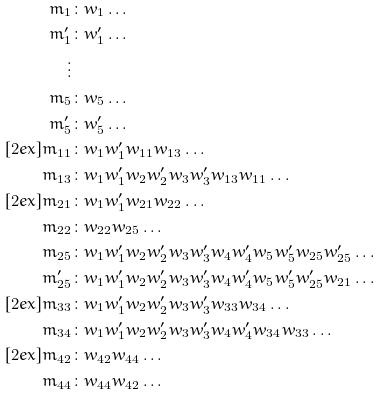<formula> <loc_0><loc_0><loc_500><loc_500>m _ { 1 } & \colon w _ { 1 } \dots \\ m _ { 1 } ^ { \prime } & \colon w _ { 1 } ^ { \prime } \dots \\ \vdots \\ m _ { 5 } & \colon w _ { 5 } \dots \\ m _ { 5 } ^ { \prime } & \colon w _ { 5 } ^ { \prime } \dots \\ [ 2 e x ] m _ { 1 1 } & \colon w _ { 1 } w _ { 1 } ^ { \prime } w _ { 1 1 } w _ { 1 3 } \dots \\ m _ { 1 3 } & \colon w _ { 1 } w _ { 1 } ^ { \prime } w _ { 2 } w _ { 2 } ^ { \prime } w _ { 3 } w _ { 3 } ^ { \prime } w _ { 1 3 } w _ { 1 1 } \dots \\ [ 2 e x ] m _ { 2 1 } & \colon w _ { 1 } w _ { 1 } ^ { \prime } w _ { 2 1 } w _ { 2 2 } \dots \\ m _ { 2 2 } & \colon w _ { 2 2 } w _ { 2 5 } \dots \\ m _ { 2 5 } & \colon w _ { 1 } w _ { 1 } ^ { \prime } w _ { 2 } w _ { 2 } ^ { \prime } w _ { 3 } w _ { 3 } ^ { \prime } w _ { 4 } w _ { 4 } ^ { \prime } w _ { 5 } w _ { 5 } ^ { \prime } w _ { 2 5 } w _ { 2 5 } ^ { \prime } \dots \\ m _ { 2 5 } ^ { \prime } & \colon w _ { 1 } w _ { 1 } ^ { \prime } w _ { 2 } w _ { 2 } ^ { \prime } w _ { 3 } w _ { 3 } ^ { \prime } w _ { 4 } w _ { 4 } ^ { \prime } w _ { 5 } w _ { 5 } ^ { \prime } w _ { 2 5 } ^ { \prime } w _ { 2 1 } \dots \\ [ 2 e x ] m _ { 3 3 } & \colon w _ { 1 } w _ { 1 } ^ { \prime } w _ { 2 } w _ { 2 } ^ { \prime } w _ { 3 } w _ { 3 } ^ { \prime } w _ { 3 3 } w _ { 3 4 } \dots \\ m _ { 3 4 } & \colon w _ { 1 } w _ { 1 } ^ { \prime } w _ { 2 } w _ { 2 } ^ { \prime } w _ { 3 } w _ { 3 } ^ { \prime } w _ { 4 } w _ { 4 } ^ { \prime } w _ { 3 4 } w _ { 3 3 } \dots \\ [ 2 e x ] m _ { 4 2 } & \colon w _ { 4 2 } w _ { 4 4 } \dots \\ m _ { 4 4 } & \colon w _ { 4 4 } w _ { 4 2 } \dots</formula> 